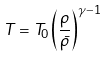<formula> <loc_0><loc_0><loc_500><loc_500>T = T _ { 0 } \left ( \frac { \rho } { \bar { \rho } } \right ) ^ { \gamma - 1 }</formula> 